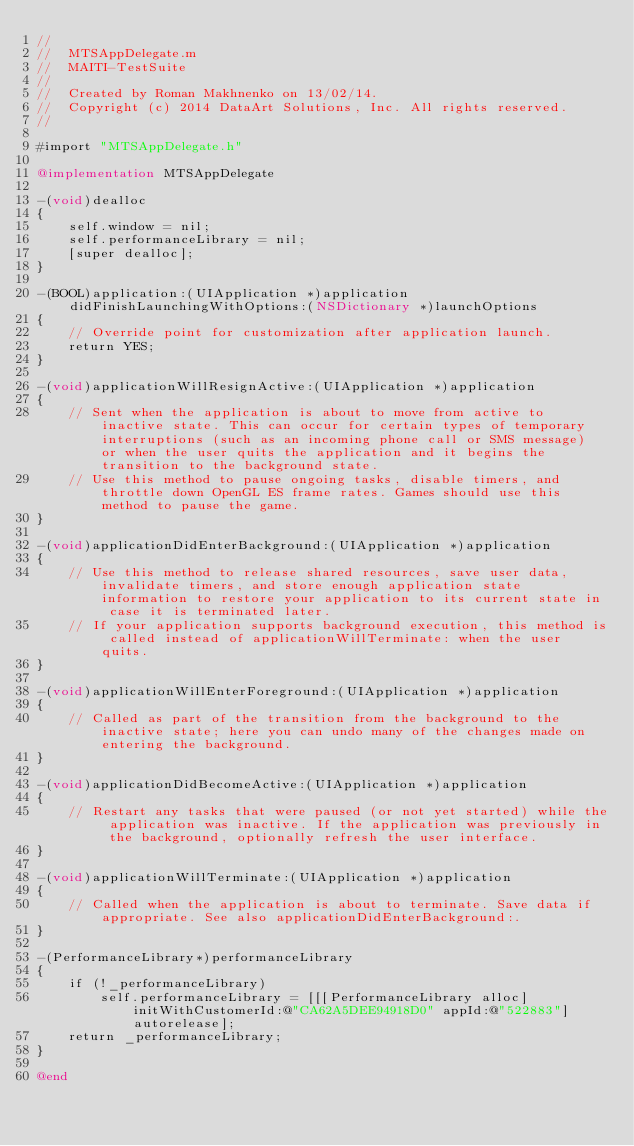<code> <loc_0><loc_0><loc_500><loc_500><_ObjectiveC_>//
//  MTSAppDelegate.m
//  MAITI-TestSuite
//
//  Created by Roman Makhnenko on 13/02/14.
//  Copyright (c) 2014 DataArt Solutions, Inc. All rights reserved.
//

#import "MTSAppDelegate.h"

@implementation MTSAppDelegate

-(void)dealloc
{
    self.window = nil;
    self.performanceLibrary = nil;
    [super dealloc];
}

-(BOOL)application:(UIApplication *)application didFinishLaunchingWithOptions:(NSDictionary *)launchOptions
{
    // Override point for customization after application launch.
    return YES;
}
							
-(void)applicationWillResignActive:(UIApplication *)application
{
    // Sent when the application is about to move from active to inactive state. This can occur for certain types of temporary interruptions (such as an incoming phone call or SMS message) or when the user quits the application and it begins the transition to the background state.
    // Use this method to pause ongoing tasks, disable timers, and throttle down OpenGL ES frame rates. Games should use this method to pause the game.
}

-(void)applicationDidEnterBackground:(UIApplication *)application
{
    // Use this method to release shared resources, save user data, invalidate timers, and store enough application state information to restore your application to its current state in case it is terminated later. 
    // If your application supports background execution, this method is called instead of applicationWillTerminate: when the user quits.
}

-(void)applicationWillEnterForeground:(UIApplication *)application
{
    // Called as part of the transition from the background to the inactive state; here you can undo many of the changes made on entering the background.
}

-(void)applicationDidBecomeActive:(UIApplication *)application
{
    // Restart any tasks that were paused (or not yet started) while the application was inactive. If the application was previously in the background, optionally refresh the user interface.
}

-(void)applicationWillTerminate:(UIApplication *)application
{
    // Called when the application is about to terminate. Save data if appropriate. See also applicationDidEnterBackground:.
}

-(PerformanceLibrary*)performanceLibrary
{
    if (!_performanceLibrary)
        self.performanceLibrary = [[[PerformanceLibrary alloc] initWithCustomerId:@"CA62A5DEE94918D0" appId:@"522883"] autorelease];
    return _performanceLibrary;
}

@end
</code> 